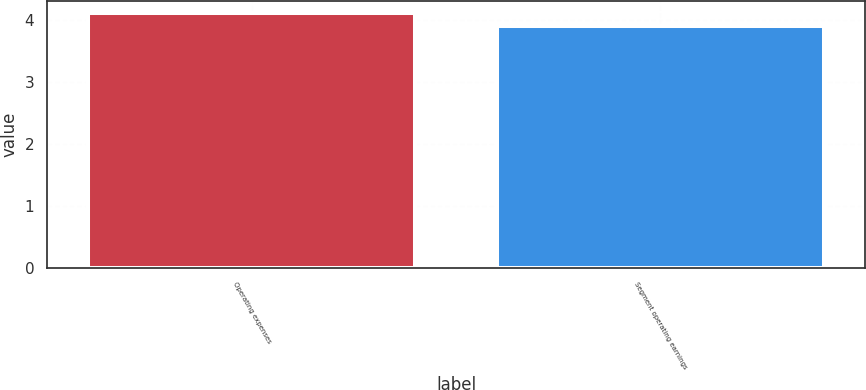Convert chart. <chart><loc_0><loc_0><loc_500><loc_500><bar_chart><fcel>Operating expenses<fcel>Segment operating earnings<nl><fcel>4.1<fcel>3.9<nl></chart> 